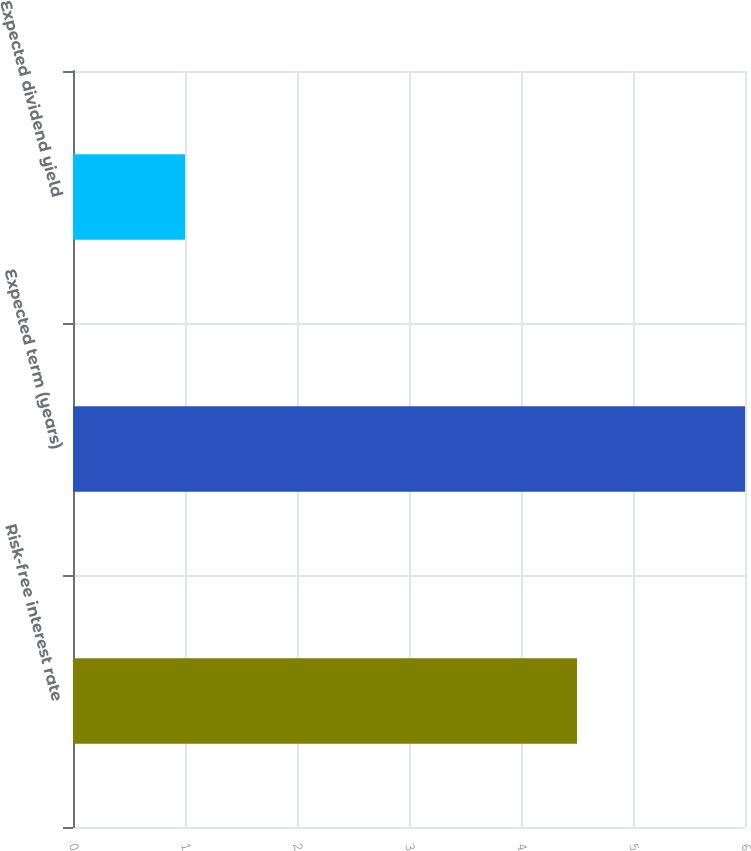<chart> <loc_0><loc_0><loc_500><loc_500><bar_chart><fcel>Risk-free interest rate<fcel>Expected term (years)<fcel>Expected dividend yield<nl><fcel>4.5<fcel>6<fcel>1<nl></chart> 